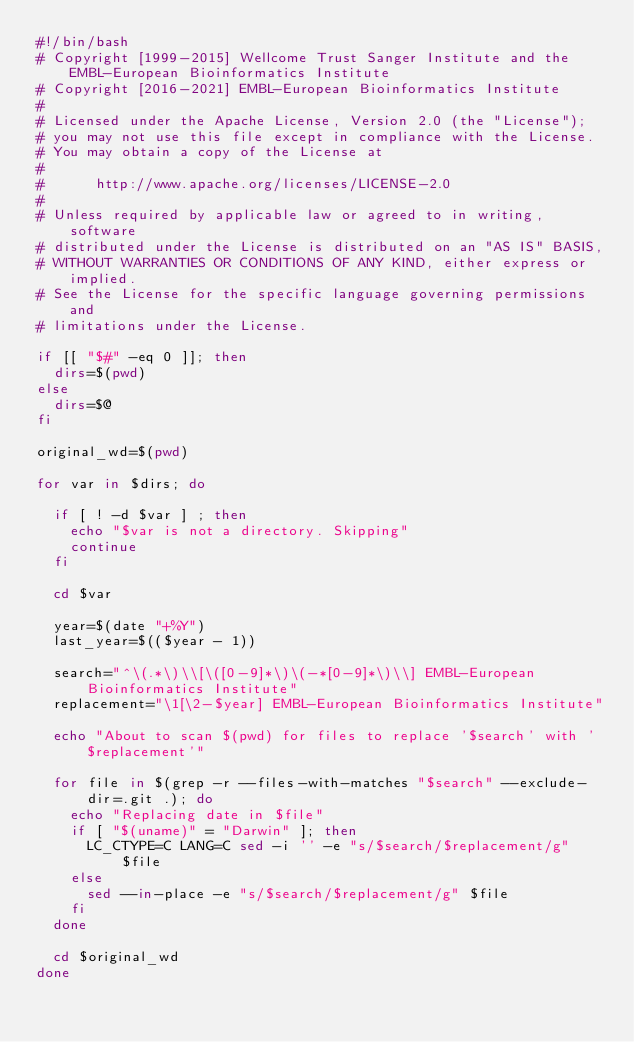Convert code to text. <code><loc_0><loc_0><loc_500><loc_500><_Bash_>#!/bin/bash
# Copyright [1999-2015] Wellcome Trust Sanger Institute and the EMBL-European Bioinformatics Institute
# Copyright [2016-2021] EMBL-European Bioinformatics Institute
# 
# Licensed under the Apache License, Version 2.0 (the "License");
# you may not use this file except in compliance with the License.
# You may obtain a copy of the License at
# 
#      http://www.apache.org/licenses/LICENSE-2.0
# 
# Unless required by applicable law or agreed to in writing, software
# distributed under the License is distributed on an "AS IS" BASIS,
# WITHOUT WARRANTIES OR CONDITIONS OF ANY KIND, either express or implied.
# See the License for the specific language governing permissions and
# limitations under the License.

if [[ "$#" -eq 0 ]]; then
  dirs=$(pwd)
else
  dirs=$@
fi

original_wd=$(pwd)

for var in $dirs; do

  if [ ! -d $var ] ; then
    echo "$var is not a directory. Skipping"
    continue
  fi

  cd $var

  year=$(date "+%Y")
  last_year=$(($year - 1))

  search="^\(.*\)\\[\([0-9]*\)\(-*[0-9]*\)\\] EMBL-European Bioinformatics Institute"
  replacement="\1[\2-$year] EMBL-European Bioinformatics Institute"

  echo "About to scan $(pwd) for files to replace '$search' with '$replacement'"

  for file in $(grep -r --files-with-matches "$search" --exclude-dir=.git .); do
    echo "Replacing date in $file"
    if [ "$(uname)" = "Darwin" ]; then
      LC_CTYPE=C LANG=C sed -i '' -e "s/$search/$replacement/g" $file
    else
      sed --in-place -e "s/$search/$replacement/g" $file
    fi
  done

  cd $original_wd
done
</code> 